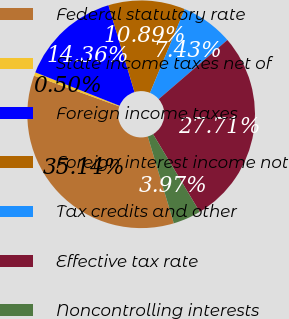<chart> <loc_0><loc_0><loc_500><loc_500><pie_chart><fcel>Federal statutory rate<fcel>State income taxes net of<fcel>Foreign income taxes<fcel>Foreign interest income not<fcel>Tax credits and other<fcel>Effective tax rate<fcel>Noncontrolling interests<nl><fcel>35.14%<fcel>0.5%<fcel>14.36%<fcel>10.89%<fcel>7.43%<fcel>27.71%<fcel>3.97%<nl></chart> 